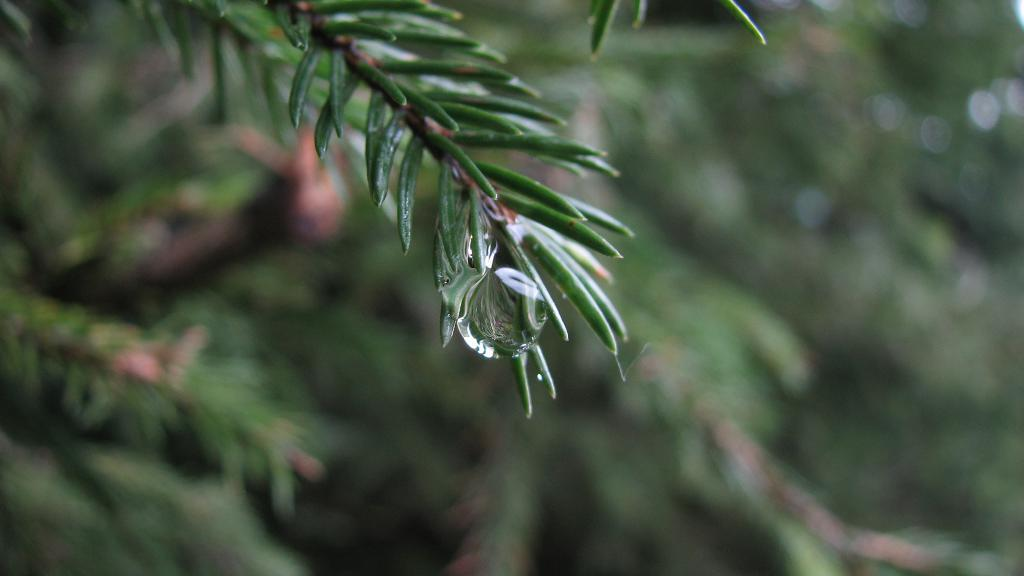What color are the leaves in the image? The leaves in the image are green. What can be seen in the center of the image? There is a water drop in the center of the image. How would you describe the overall clarity of the image? The image is blurry in the background. How many legs does the jellyfish have in the image? There is no jellyfish present in the image. 